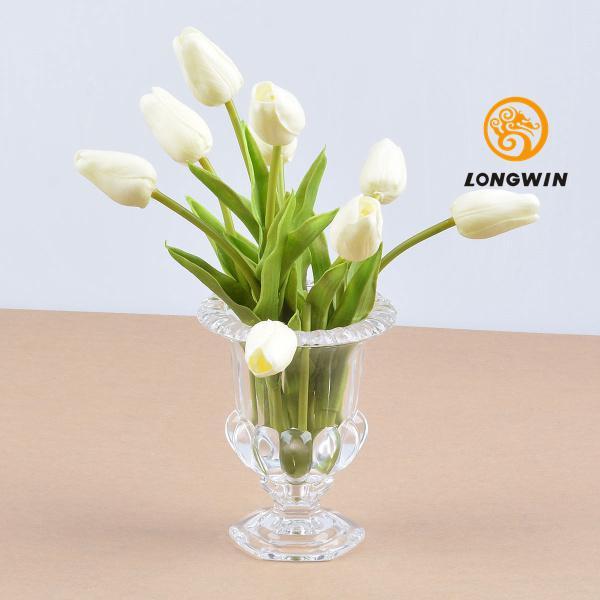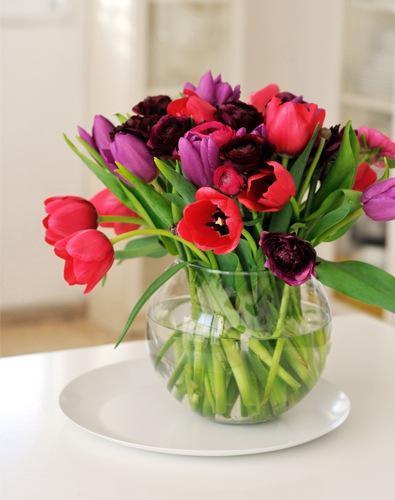The first image is the image on the left, the second image is the image on the right. Evaluate the accuracy of this statement regarding the images: "There are two clear vases in one of the images.". Is it true? Answer yes or no. No. 